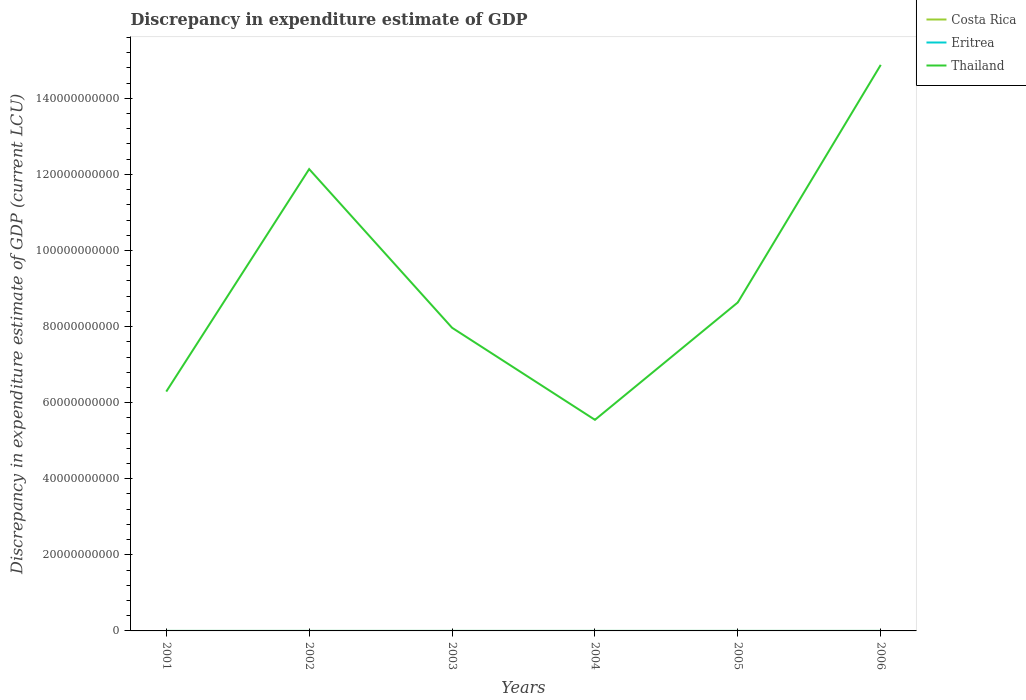How many different coloured lines are there?
Your answer should be compact. 3. Across all years, what is the maximum discrepancy in expenditure estimate of GDP in Costa Rica?
Your response must be concise. 0. What is the total discrepancy in expenditure estimate of GDP in Thailand in the graph?
Ensure brevity in your answer.  -6.66e+09. What is the difference between the highest and the second highest discrepancy in expenditure estimate of GDP in Thailand?
Offer a terse response. 9.33e+1. What is the difference between the highest and the lowest discrepancy in expenditure estimate of GDP in Thailand?
Give a very brief answer. 2. How many lines are there?
Offer a very short reply. 3. How many years are there in the graph?
Offer a terse response. 6. Are the values on the major ticks of Y-axis written in scientific E-notation?
Offer a terse response. No. What is the title of the graph?
Keep it short and to the point. Discrepancy in expenditure estimate of GDP. What is the label or title of the Y-axis?
Offer a very short reply. Discrepancy in expenditure estimate of GDP (current LCU). What is the Discrepancy in expenditure estimate of GDP (current LCU) of Eritrea in 2001?
Provide a short and direct response. 0. What is the Discrepancy in expenditure estimate of GDP (current LCU) in Thailand in 2001?
Your answer should be compact. 6.29e+1. What is the Discrepancy in expenditure estimate of GDP (current LCU) of Costa Rica in 2002?
Give a very brief answer. 0. What is the Discrepancy in expenditure estimate of GDP (current LCU) in Eritrea in 2002?
Your answer should be compact. 0. What is the Discrepancy in expenditure estimate of GDP (current LCU) in Thailand in 2002?
Your response must be concise. 1.21e+11. What is the Discrepancy in expenditure estimate of GDP (current LCU) in Eritrea in 2003?
Ensure brevity in your answer.  9.971e-5. What is the Discrepancy in expenditure estimate of GDP (current LCU) in Thailand in 2003?
Your answer should be compact. 7.97e+1. What is the Discrepancy in expenditure estimate of GDP (current LCU) in Eritrea in 2004?
Give a very brief answer. 0. What is the Discrepancy in expenditure estimate of GDP (current LCU) in Thailand in 2004?
Make the answer very short. 5.55e+1. What is the Discrepancy in expenditure estimate of GDP (current LCU) in Eritrea in 2005?
Provide a short and direct response. 2e-7. What is the Discrepancy in expenditure estimate of GDP (current LCU) in Thailand in 2005?
Provide a succinct answer. 8.64e+1. What is the Discrepancy in expenditure estimate of GDP (current LCU) of Eritrea in 2006?
Offer a terse response. 0. What is the Discrepancy in expenditure estimate of GDP (current LCU) of Thailand in 2006?
Provide a short and direct response. 1.49e+11. Across all years, what is the maximum Discrepancy in expenditure estimate of GDP (current LCU) of Costa Rica?
Your answer should be compact. 2.00e+05. Across all years, what is the maximum Discrepancy in expenditure estimate of GDP (current LCU) in Eritrea?
Offer a terse response. 0. Across all years, what is the maximum Discrepancy in expenditure estimate of GDP (current LCU) in Thailand?
Offer a terse response. 1.49e+11. Across all years, what is the minimum Discrepancy in expenditure estimate of GDP (current LCU) of Costa Rica?
Make the answer very short. 0. Across all years, what is the minimum Discrepancy in expenditure estimate of GDP (current LCU) in Eritrea?
Your response must be concise. 0. Across all years, what is the minimum Discrepancy in expenditure estimate of GDP (current LCU) in Thailand?
Your answer should be compact. 5.55e+1. What is the total Discrepancy in expenditure estimate of GDP (current LCU) in Costa Rica in the graph?
Offer a very short reply. 3.00e+05. What is the total Discrepancy in expenditure estimate of GDP (current LCU) in Thailand in the graph?
Provide a short and direct response. 5.55e+11. What is the difference between the Discrepancy in expenditure estimate of GDP (current LCU) of Thailand in 2001 and that in 2002?
Your answer should be very brief. -5.85e+1. What is the difference between the Discrepancy in expenditure estimate of GDP (current LCU) of Eritrea in 2001 and that in 2003?
Your response must be concise. 0. What is the difference between the Discrepancy in expenditure estimate of GDP (current LCU) in Thailand in 2001 and that in 2003?
Your response must be concise. -1.68e+1. What is the difference between the Discrepancy in expenditure estimate of GDP (current LCU) of Eritrea in 2001 and that in 2004?
Make the answer very short. 0. What is the difference between the Discrepancy in expenditure estimate of GDP (current LCU) in Thailand in 2001 and that in 2004?
Offer a very short reply. 7.42e+09. What is the difference between the Discrepancy in expenditure estimate of GDP (current LCU) of Thailand in 2001 and that in 2005?
Keep it short and to the point. -2.34e+1. What is the difference between the Discrepancy in expenditure estimate of GDP (current LCU) in Thailand in 2001 and that in 2006?
Make the answer very short. -8.59e+1. What is the difference between the Discrepancy in expenditure estimate of GDP (current LCU) in Eritrea in 2002 and that in 2003?
Give a very brief answer. 0. What is the difference between the Discrepancy in expenditure estimate of GDP (current LCU) in Thailand in 2002 and that in 2003?
Make the answer very short. 4.17e+1. What is the difference between the Discrepancy in expenditure estimate of GDP (current LCU) of Eritrea in 2002 and that in 2004?
Provide a succinct answer. 0. What is the difference between the Discrepancy in expenditure estimate of GDP (current LCU) of Thailand in 2002 and that in 2004?
Your response must be concise. 6.59e+1. What is the difference between the Discrepancy in expenditure estimate of GDP (current LCU) in Eritrea in 2002 and that in 2005?
Your answer should be compact. 0. What is the difference between the Discrepancy in expenditure estimate of GDP (current LCU) of Thailand in 2002 and that in 2005?
Give a very brief answer. 3.50e+1. What is the difference between the Discrepancy in expenditure estimate of GDP (current LCU) in Thailand in 2002 and that in 2006?
Offer a very short reply. -2.74e+1. What is the difference between the Discrepancy in expenditure estimate of GDP (current LCU) of Eritrea in 2003 and that in 2004?
Provide a succinct answer. -0. What is the difference between the Discrepancy in expenditure estimate of GDP (current LCU) of Thailand in 2003 and that in 2004?
Offer a very short reply. 2.42e+1. What is the difference between the Discrepancy in expenditure estimate of GDP (current LCU) of Eritrea in 2003 and that in 2005?
Your response must be concise. 0. What is the difference between the Discrepancy in expenditure estimate of GDP (current LCU) of Thailand in 2003 and that in 2005?
Offer a very short reply. -6.66e+09. What is the difference between the Discrepancy in expenditure estimate of GDP (current LCU) of Thailand in 2003 and that in 2006?
Provide a succinct answer. -6.91e+1. What is the difference between the Discrepancy in expenditure estimate of GDP (current LCU) in Eritrea in 2004 and that in 2005?
Ensure brevity in your answer.  0. What is the difference between the Discrepancy in expenditure estimate of GDP (current LCU) in Thailand in 2004 and that in 2005?
Provide a short and direct response. -3.09e+1. What is the difference between the Discrepancy in expenditure estimate of GDP (current LCU) of Thailand in 2004 and that in 2006?
Offer a terse response. -9.33e+1. What is the difference between the Discrepancy in expenditure estimate of GDP (current LCU) in Thailand in 2005 and that in 2006?
Give a very brief answer. -6.24e+1. What is the difference between the Discrepancy in expenditure estimate of GDP (current LCU) in Eritrea in 2001 and the Discrepancy in expenditure estimate of GDP (current LCU) in Thailand in 2002?
Offer a very short reply. -1.21e+11. What is the difference between the Discrepancy in expenditure estimate of GDP (current LCU) of Eritrea in 2001 and the Discrepancy in expenditure estimate of GDP (current LCU) of Thailand in 2003?
Give a very brief answer. -7.97e+1. What is the difference between the Discrepancy in expenditure estimate of GDP (current LCU) in Eritrea in 2001 and the Discrepancy in expenditure estimate of GDP (current LCU) in Thailand in 2004?
Your answer should be compact. -5.55e+1. What is the difference between the Discrepancy in expenditure estimate of GDP (current LCU) of Eritrea in 2001 and the Discrepancy in expenditure estimate of GDP (current LCU) of Thailand in 2005?
Make the answer very short. -8.64e+1. What is the difference between the Discrepancy in expenditure estimate of GDP (current LCU) in Eritrea in 2001 and the Discrepancy in expenditure estimate of GDP (current LCU) in Thailand in 2006?
Ensure brevity in your answer.  -1.49e+11. What is the difference between the Discrepancy in expenditure estimate of GDP (current LCU) in Eritrea in 2002 and the Discrepancy in expenditure estimate of GDP (current LCU) in Thailand in 2003?
Your response must be concise. -7.97e+1. What is the difference between the Discrepancy in expenditure estimate of GDP (current LCU) of Eritrea in 2002 and the Discrepancy in expenditure estimate of GDP (current LCU) of Thailand in 2004?
Ensure brevity in your answer.  -5.55e+1. What is the difference between the Discrepancy in expenditure estimate of GDP (current LCU) in Eritrea in 2002 and the Discrepancy in expenditure estimate of GDP (current LCU) in Thailand in 2005?
Make the answer very short. -8.64e+1. What is the difference between the Discrepancy in expenditure estimate of GDP (current LCU) in Eritrea in 2002 and the Discrepancy in expenditure estimate of GDP (current LCU) in Thailand in 2006?
Give a very brief answer. -1.49e+11. What is the difference between the Discrepancy in expenditure estimate of GDP (current LCU) of Eritrea in 2003 and the Discrepancy in expenditure estimate of GDP (current LCU) of Thailand in 2004?
Give a very brief answer. -5.55e+1. What is the difference between the Discrepancy in expenditure estimate of GDP (current LCU) in Eritrea in 2003 and the Discrepancy in expenditure estimate of GDP (current LCU) in Thailand in 2005?
Ensure brevity in your answer.  -8.64e+1. What is the difference between the Discrepancy in expenditure estimate of GDP (current LCU) of Eritrea in 2003 and the Discrepancy in expenditure estimate of GDP (current LCU) of Thailand in 2006?
Your answer should be very brief. -1.49e+11. What is the difference between the Discrepancy in expenditure estimate of GDP (current LCU) of Eritrea in 2004 and the Discrepancy in expenditure estimate of GDP (current LCU) of Thailand in 2005?
Ensure brevity in your answer.  -8.64e+1. What is the difference between the Discrepancy in expenditure estimate of GDP (current LCU) in Eritrea in 2004 and the Discrepancy in expenditure estimate of GDP (current LCU) in Thailand in 2006?
Provide a short and direct response. -1.49e+11. What is the difference between the Discrepancy in expenditure estimate of GDP (current LCU) of Costa Rica in 2005 and the Discrepancy in expenditure estimate of GDP (current LCU) of Thailand in 2006?
Offer a terse response. -1.49e+11. What is the difference between the Discrepancy in expenditure estimate of GDP (current LCU) of Eritrea in 2005 and the Discrepancy in expenditure estimate of GDP (current LCU) of Thailand in 2006?
Your answer should be compact. -1.49e+11. What is the average Discrepancy in expenditure estimate of GDP (current LCU) of Thailand per year?
Provide a succinct answer. 9.24e+1. In the year 2001, what is the difference between the Discrepancy in expenditure estimate of GDP (current LCU) in Eritrea and Discrepancy in expenditure estimate of GDP (current LCU) in Thailand?
Your answer should be compact. -6.29e+1. In the year 2002, what is the difference between the Discrepancy in expenditure estimate of GDP (current LCU) in Eritrea and Discrepancy in expenditure estimate of GDP (current LCU) in Thailand?
Provide a succinct answer. -1.21e+11. In the year 2003, what is the difference between the Discrepancy in expenditure estimate of GDP (current LCU) in Eritrea and Discrepancy in expenditure estimate of GDP (current LCU) in Thailand?
Ensure brevity in your answer.  -7.97e+1. In the year 2004, what is the difference between the Discrepancy in expenditure estimate of GDP (current LCU) of Eritrea and Discrepancy in expenditure estimate of GDP (current LCU) of Thailand?
Your answer should be compact. -5.55e+1. In the year 2005, what is the difference between the Discrepancy in expenditure estimate of GDP (current LCU) in Costa Rica and Discrepancy in expenditure estimate of GDP (current LCU) in Eritrea?
Offer a terse response. 1.00e+05. In the year 2005, what is the difference between the Discrepancy in expenditure estimate of GDP (current LCU) in Costa Rica and Discrepancy in expenditure estimate of GDP (current LCU) in Thailand?
Offer a terse response. -8.64e+1. In the year 2005, what is the difference between the Discrepancy in expenditure estimate of GDP (current LCU) of Eritrea and Discrepancy in expenditure estimate of GDP (current LCU) of Thailand?
Your response must be concise. -8.64e+1. In the year 2006, what is the difference between the Discrepancy in expenditure estimate of GDP (current LCU) in Costa Rica and Discrepancy in expenditure estimate of GDP (current LCU) in Thailand?
Your answer should be very brief. -1.49e+11. What is the ratio of the Discrepancy in expenditure estimate of GDP (current LCU) in Eritrea in 2001 to that in 2002?
Make the answer very short. 0.99. What is the ratio of the Discrepancy in expenditure estimate of GDP (current LCU) of Thailand in 2001 to that in 2002?
Make the answer very short. 0.52. What is the ratio of the Discrepancy in expenditure estimate of GDP (current LCU) in Thailand in 2001 to that in 2003?
Give a very brief answer. 0.79. What is the ratio of the Discrepancy in expenditure estimate of GDP (current LCU) of Eritrea in 2001 to that in 2004?
Give a very brief answer. 1. What is the ratio of the Discrepancy in expenditure estimate of GDP (current LCU) of Thailand in 2001 to that in 2004?
Your answer should be compact. 1.13. What is the ratio of the Discrepancy in expenditure estimate of GDP (current LCU) of Eritrea in 2001 to that in 2005?
Keep it short and to the point. 501.05. What is the ratio of the Discrepancy in expenditure estimate of GDP (current LCU) of Thailand in 2001 to that in 2005?
Ensure brevity in your answer.  0.73. What is the ratio of the Discrepancy in expenditure estimate of GDP (current LCU) of Thailand in 2001 to that in 2006?
Your answer should be compact. 0.42. What is the ratio of the Discrepancy in expenditure estimate of GDP (current LCU) in Thailand in 2002 to that in 2003?
Your answer should be compact. 1.52. What is the ratio of the Discrepancy in expenditure estimate of GDP (current LCU) in Eritrea in 2002 to that in 2004?
Keep it short and to the point. 1.01. What is the ratio of the Discrepancy in expenditure estimate of GDP (current LCU) in Thailand in 2002 to that in 2004?
Your response must be concise. 2.19. What is the ratio of the Discrepancy in expenditure estimate of GDP (current LCU) in Eritrea in 2002 to that in 2005?
Make the answer very short. 507.5. What is the ratio of the Discrepancy in expenditure estimate of GDP (current LCU) of Thailand in 2002 to that in 2005?
Keep it short and to the point. 1.41. What is the ratio of the Discrepancy in expenditure estimate of GDP (current LCU) in Thailand in 2002 to that in 2006?
Provide a short and direct response. 0.82. What is the ratio of the Discrepancy in expenditure estimate of GDP (current LCU) in Eritrea in 2003 to that in 2004?
Provide a short and direct response. 1. What is the ratio of the Discrepancy in expenditure estimate of GDP (current LCU) in Thailand in 2003 to that in 2004?
Ensure brevity in your answer.  1.44. What is the ratio of the Discrepancy in expenditure estimate of GDP (current LCU) in Eritrea in 2003 to that in 2005?
Give a very brief answer. 498.55. What is the ratio of the Discrepancy in expenditure estimate of GDP (current LCU) in Thailand in 2003 to that in 2005?
Your answer should be very brief. 0.92. What is the ratio of the Discrepancy in expenditure estimate of GDP (current LCU) of Thailand in 2003 to that in 2006?
Keep it short and to the point. 0.54. What is the ratio of the Discrepancy in expenditure estimate of GDP (current LCU) in Eritrea in 2004 to that in 2005?
Give a very brief answer. 500.35. What is the ratio of the Discrepancy in expenditure estimate of GDP (current LCU) in Thailand in 2004 to that in 2005?
Ensure brevity in your answer.  0.64. What is the ratio of the Discrepancy in expenditure estimate of GDP (current LCU) in Thailand in 2004 to that in 2006?
Your response must be concise. 0.37. What is the ratio of the Discrepancy in expenditure estimate of GDP (current LCU) in Thailand in 2005 to that in 2006?
Provide a short and direct response. 0.58. What is the difference between the highest and the second highest Discrepancy in expenditure estimate of GDP (current LCU) in Thailand?
Make the answer very short. 2.74e+1. What is the difference between the highest and the lowest Discrepancy in expenditure estimate of GDP (current LCU) in Costa Rica?
Keep it short and to the point. 2.00e+05. What is the difference between the highest and the lowest Discrepancy in expenditure estimate of GDP (current LCU) of Eritrea?
Ensure brevity in your answer.  0. What is the difference between the highest and the lowest Discrepancy in expenditure estimate of GDP (current LCU) in Thailand?
Your answer should be very brief. 9.33e+1. 